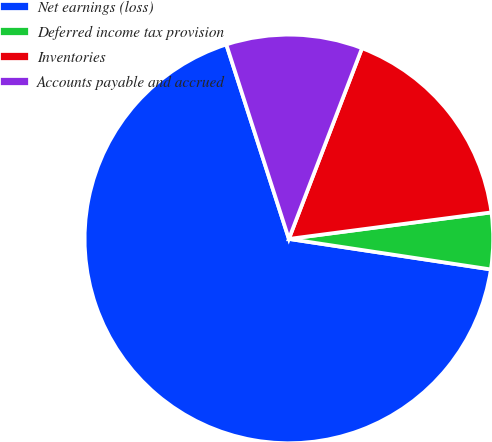Convert chart. <chart><loc_0><loc_0><loc_500><loc_500><pie_chart><fcel>Net earnings (loss)<fcel>Deferred income tax provision<fcel>Inventories<fcel>Accounts payable and accrued<nl><fcel>67.66%<fcel>4.46%<fcel>17.1%<fcel>10.78%<nl></chart> 